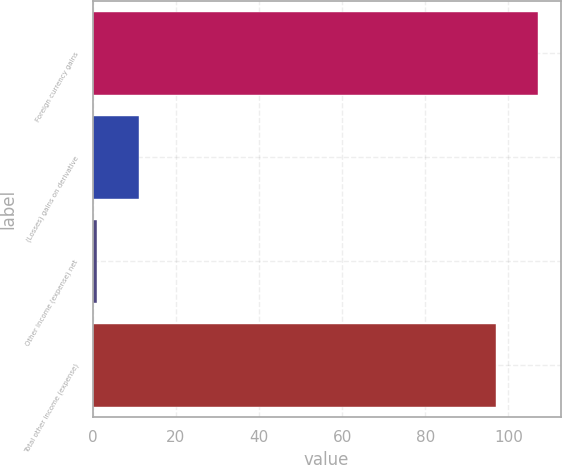Convert chart to OTSL. <chart><loc_0><loc_0><loc_500><loc_500><bar_chart><fcel>Foreign currency gains<fcel>(Losses) gains on derivative<fcel>Other income (expense) net<fcel>Total other income (expense)<nl><fcel>107.2<fcel>11.2<fcel>1<fcel>97<nl></chart> 